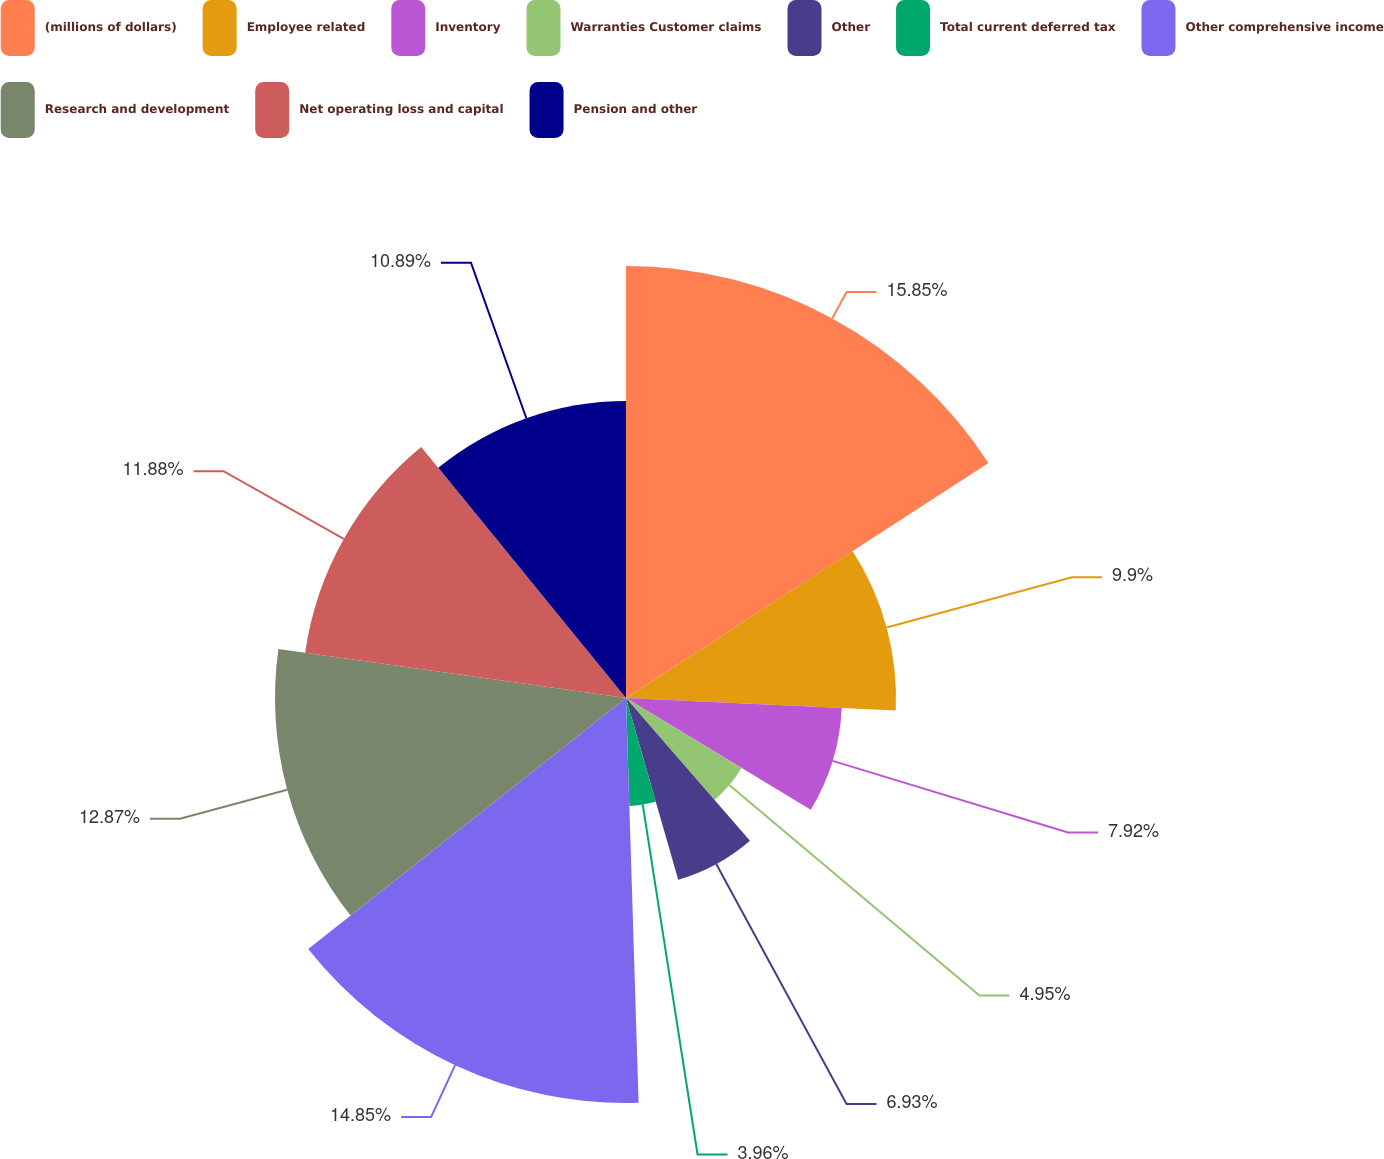<chart> <loc_0><loc_0><loc_500><loc_500><pie_chart><fcel>(millions of dollars)<fcel>Employee related<fcel>Inventory<fcel>Warranties Customer claims<fcel>Other<fcel>Total current deferred tax<fcel>Other comprehensive income<fcel>Research and development<fcel>Net operating loss and capital<fcel>Pension and other<nl><fcel>15.84%<fcel>9.9%<fcel>7.92%<fcel>4.95%<fcel>6.93%<fcel>3.96%<fcel>14.85%<fcel>12.87%<fcel>11.88%<fcel>10.89%<nl></chart> 